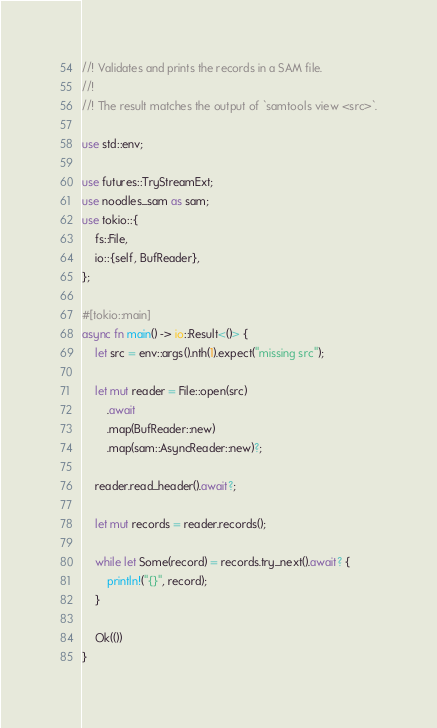<code> <loc_0><loc_0><loc_500><loc_500><_Rust_>//! Validates and prints the records in a SAM file.
//!
//! The result matches the output of `samtools view <src>`.

use std::env;

use futures::TryStreamExt;
use noodles_sam as sam;
use tokio::{
    fs::File,
    io::{self, BufReader},
};

#[tokio::main]
async fn main() -> io::Result<()> {
    let src = env::args().nth(1).expect("missing src");

    let mut reader = File::open(src)
        .await
        .map(BufReader::new)
        .map(sam::AsyncReader::new)?;

    reader.read_header().await?;

    let mut records = reader.records();

    while let Some(record) = records.try_next().await? {
        println!("{}", record);
    }

    Ok(())
}
</code> 